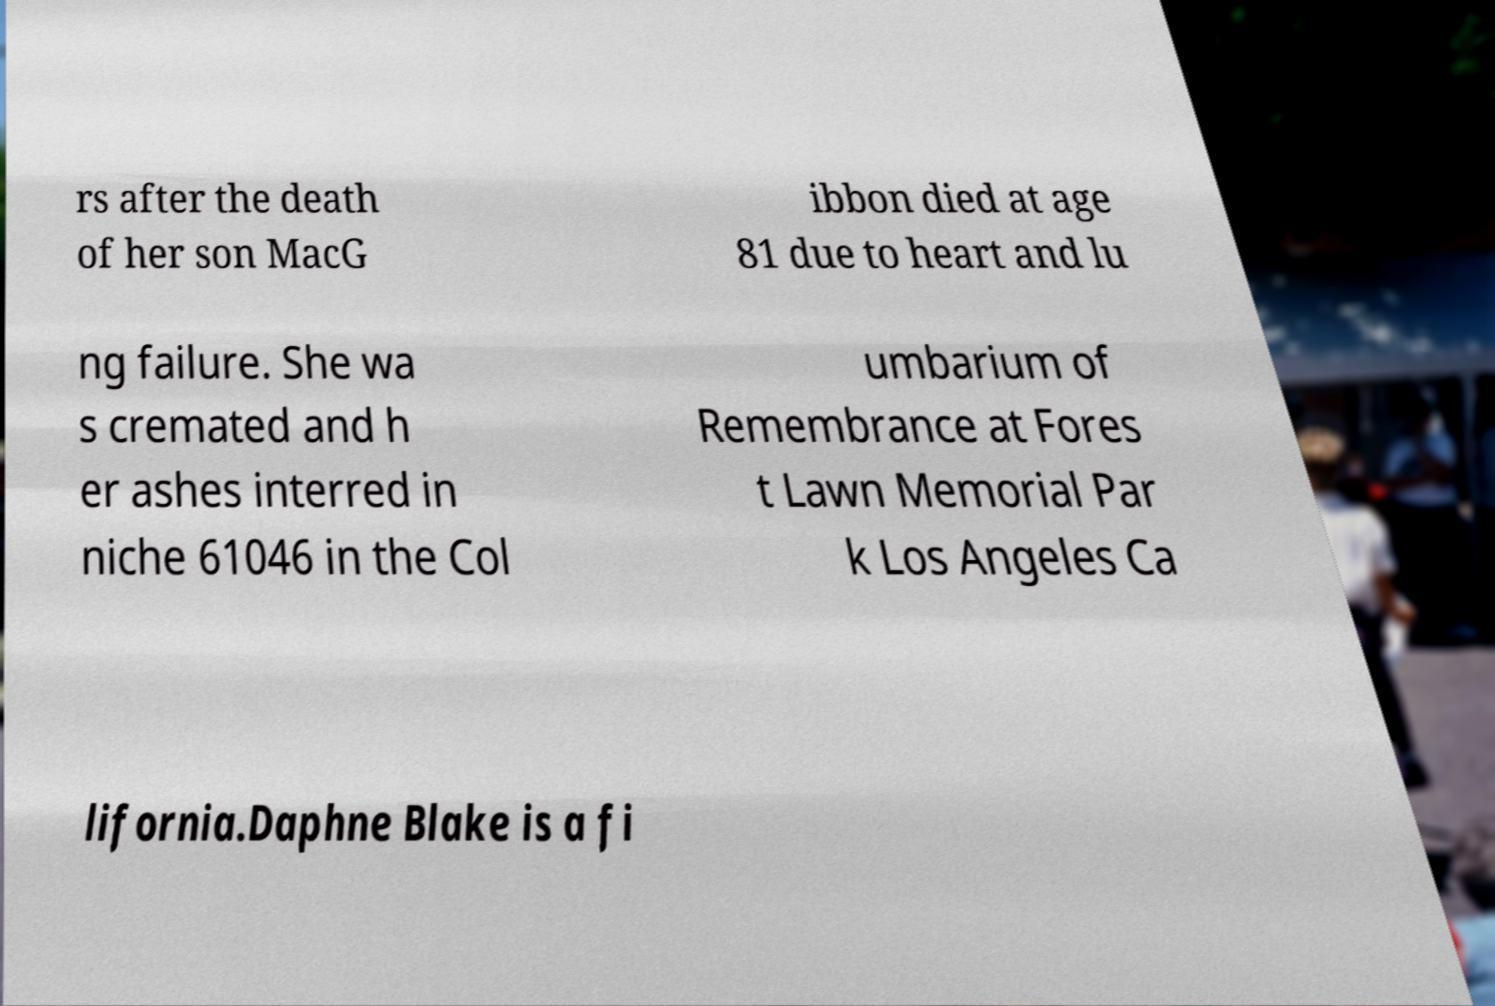Please identify and transcribe the text found in this image. rs after the death of her son MacG ibbon died at age 81 due to heart and lu ng failure. She wa s cremated and h er ashes interred in niche 61046 in the Col umbarium of Remembrance at Fores t Lawn Memorial Par k Los Angeles Ca lifornia.Daphne Blake is a fi 